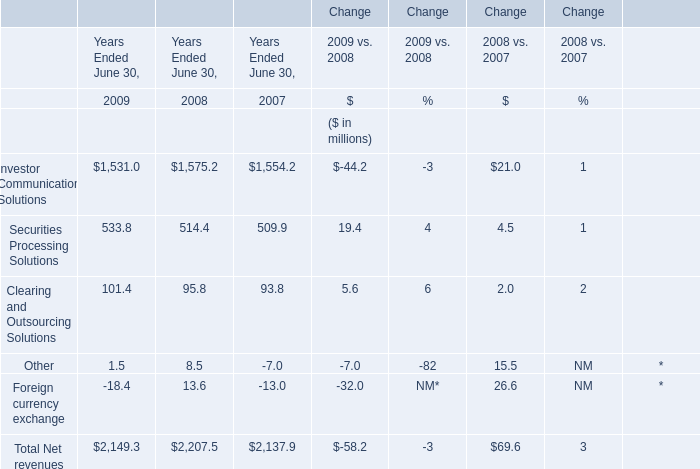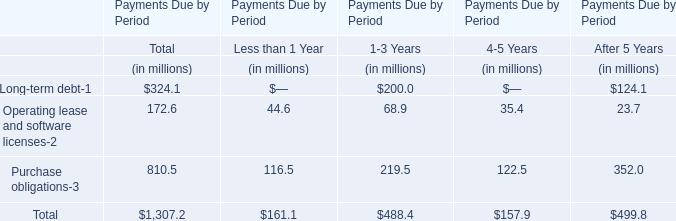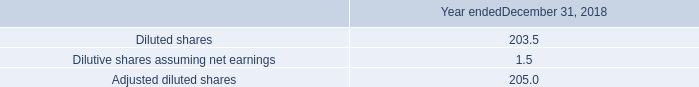what is the percent change in cash flows provided by operating activities between 2017 and 2016? 
Computations: ((1582.3 - 1632.2) / 1632.2)
Answer: -0.03057. 